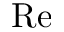<formula> <loc_0><loc_0><loc_500><loc_500>R e</formula> 